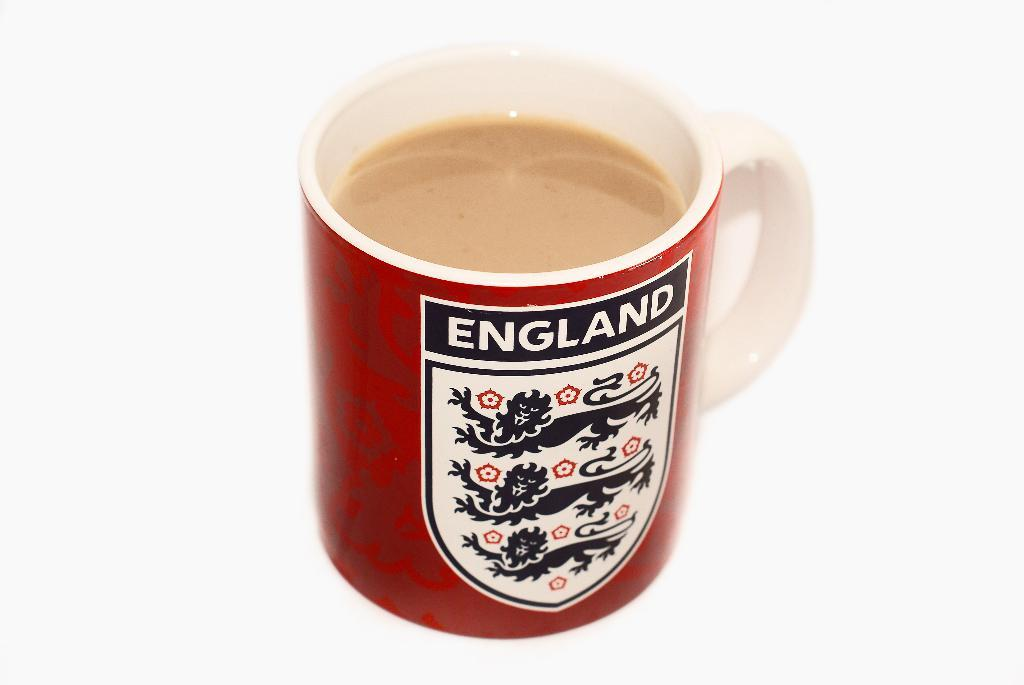What is in the cup that is visible in the image? There is a drink in the cup that is visible in the image. Is there anything else on the cup besides the drink? Yes, the cup has a sticker on it. What color is the background of the image? The background of the image is white. Reasoning: Let's think step by step by following the steps to produce the conversation. We start by identifying the main subject in the image, which is the cup with a drink. Then, we expand the conversation to include other details about the cup, such as the sticker. Finally, we describe the background of the image, which is white. Each question is designed to elicit a specific detail about the image that is known from the provided facts. Absurd Question/Answer: What type of animal is fueling the force in the image? There is no animal, fuel, or force present in the image. 